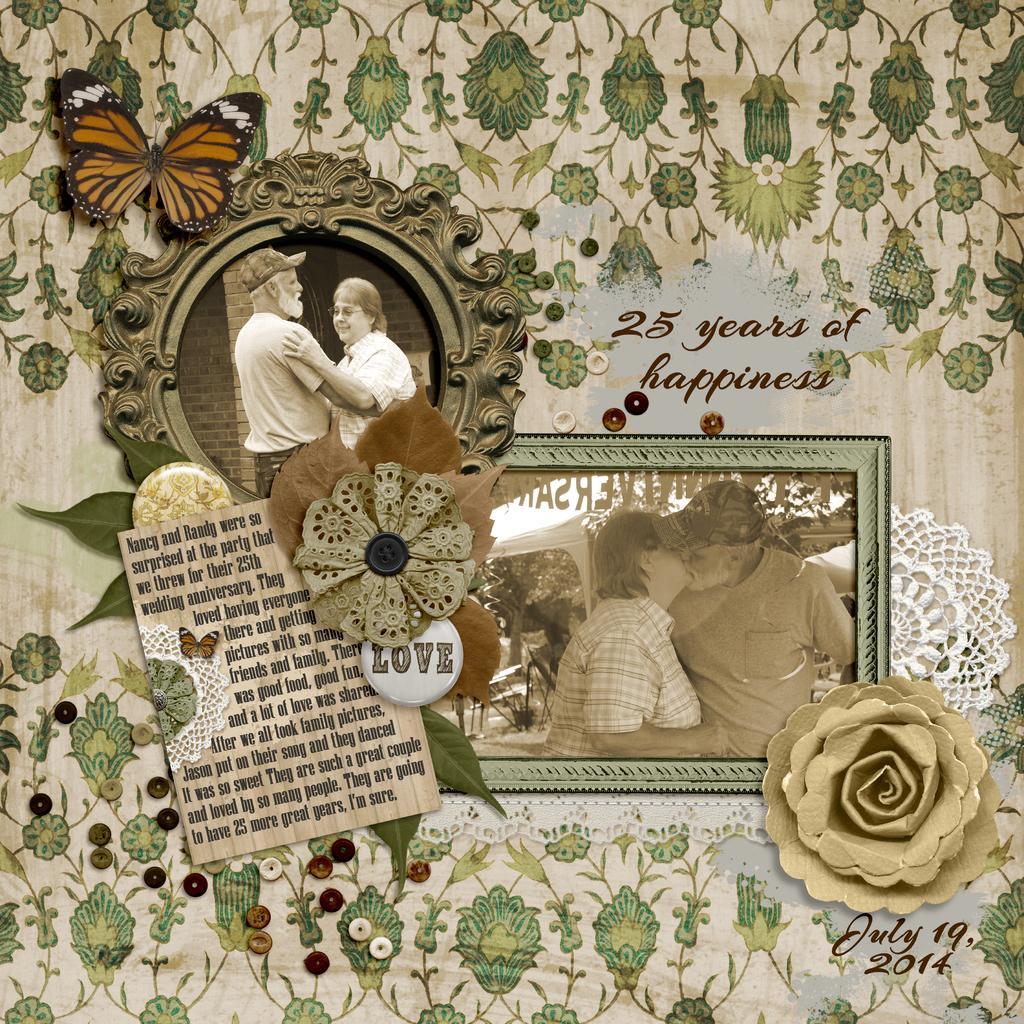Describe this image in one or two sentences. In this picture there are two photo frames. In the center of the image two persons are standing. At the top left corner two persons are there. At the bottom of the image a flower is there. At the top left corner butterfly is there. In the middle of the image some text is present. 